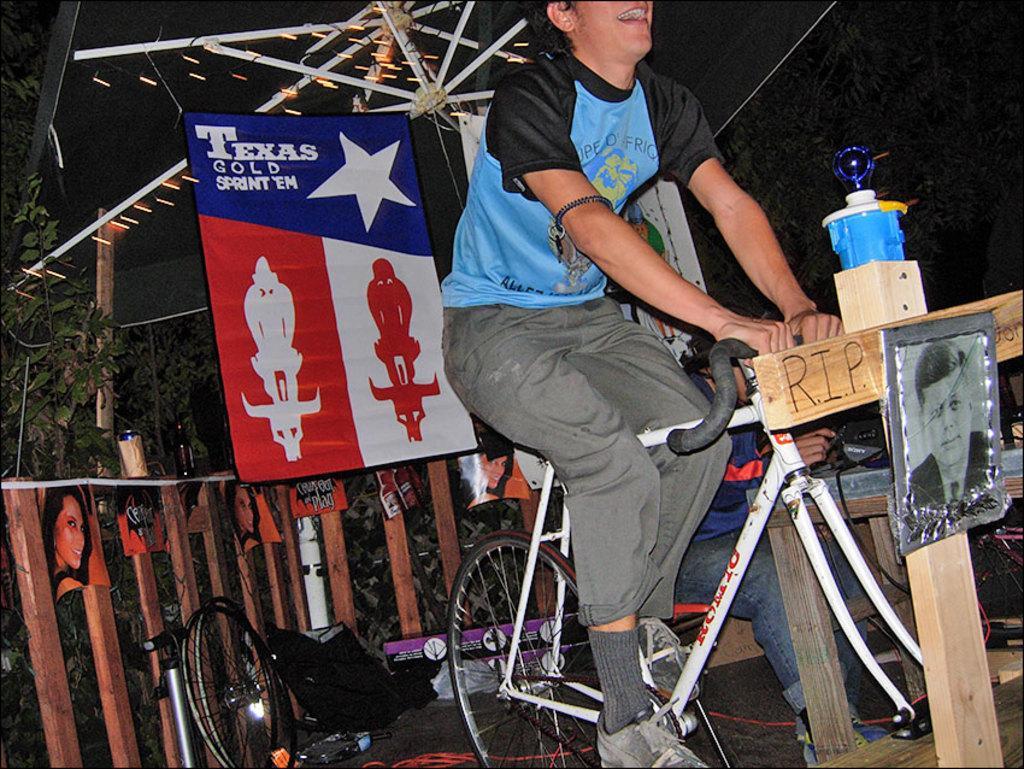How would you summarize this image in a sentence or two? This is the picture where we can see a man in black and blue tee shirt sitting on a bicycle and in front of a bicycle there is a wooden board on which it is written as rip and a photo is attached to it and behind him there is a posture of blue, red and white in color. 